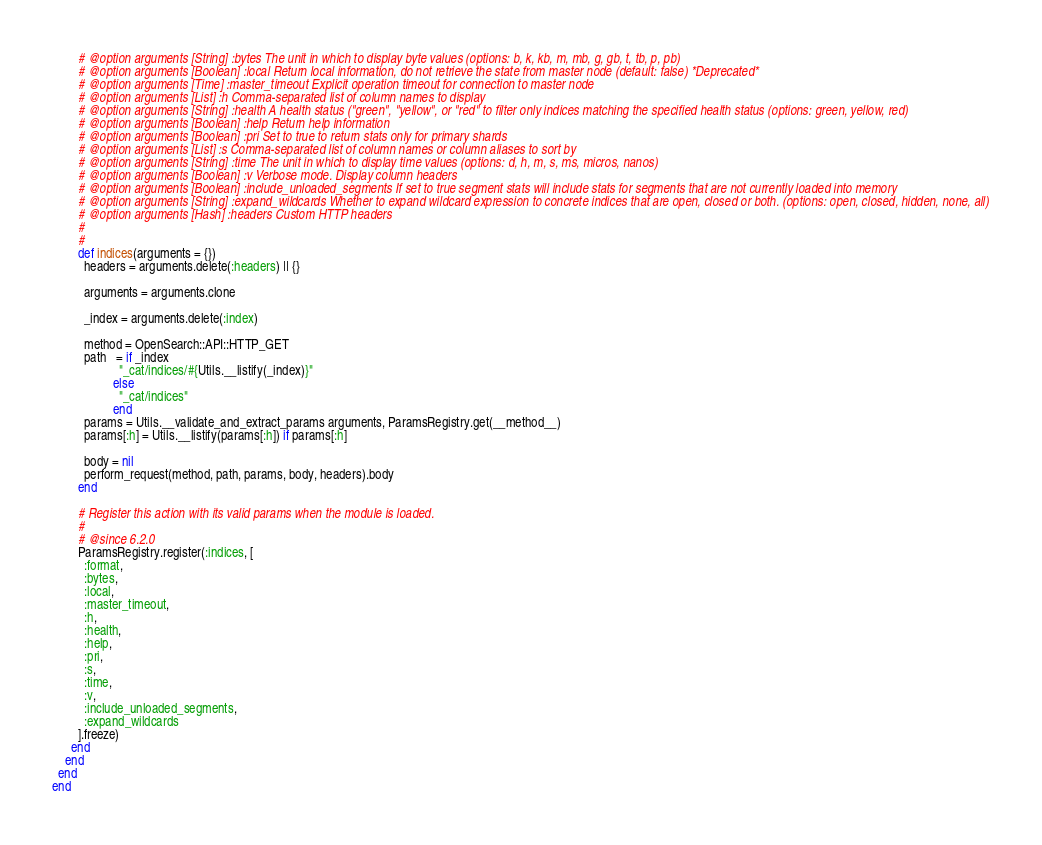Convert code to text. <code><loc_0><loc_0><loc_500><loc_500><_Ruby_>        # @option arguments [String] :bytes The unit in which to display byte values (options: b, k, kb, m, mb, g, gb, t, tb, p, pb)
        # @option arguments [Boolean] :local Return local information, do not retrieve the state from master node (default: false) *Deprecated*
        # @option arguments [Time] :master_timeout Explicit operation timeout for connection to master node
        # @option arguments [List] :h Comma-separated list of column names to display
        # @option arguments [String] :health A health status ("green", "yellow", or "red" to filter only indices matching the specified health status (options: green, yellow, red)
        # @option arguments [Boolean] :help Return help information
        # @option arguments [Boolean] :pri Set to true to return stats only for primary shards
        # @option arguments [List] :s Comma-separated list of column names or column aliases to sort by
        # @option arguments [String] :time The unit in which to display time values (options: d, h, m, s, ms, micros, nanos)
        # @option arguments [Boolean] :v Verbose mode. Display column headers
        # @option arguments [Boolean] :include_unloaded_segments If set to true segment stats will include stats for segments that are not currently loaded into memory
        # @option arguments [String] :expand_wildcards Whether to expand wildcard expression to concrete indices that are open, closed or both. (options: open, closed, hidden, none, all)
        # @option arguments [Hash] :headers Custom HTTP headers
        #
        #
        def indices(arguments = {})
          headers = arguments.delete(:headers) || {}

          arguments = arguments.clone

          _index = arguments.delete(:index)

          method = OpenSearch::API::HTTP_GET
          path   = if _index
                     "_cat/indices/#{Utils.__listify(_index)}"
                   else
                     "_cat/indices"
                   end
          params = Utils.__validate_and_extract_params arguments, ParamsRegistry.get(__method__)
          params[:h] = Utils.__listify(params[:h]) if params[:h]

          body = nil
          perform_request(method, path, params, body, headers).body
        end

        # Register this action with its valid params when the module is loaded.
        #
        # @since 6.2.0
        ParamsRegistry.register(:indices, [
          :format,
          :bytes,
          :local,
          :master_timeout,
          :h,
          :health,
          :help,
          :pri,
          :s,
          :time,
          :v,
          :include_unloaded_segments,
          :expand_wildcards
        ].freeze)
      end
    end
  end
end
</code> 